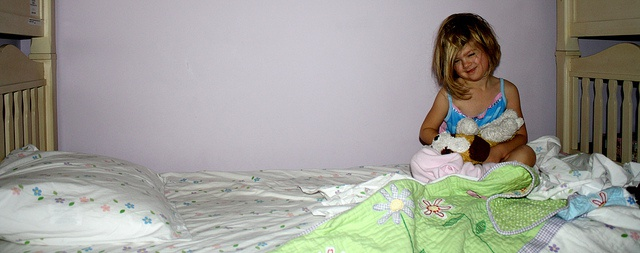Describe the objects in this image and their specific colors. I can see bed in gray, darkgray, lightgray, and lightgreen tones, people in gray, black, and maroon tones, and teddy bear in gray, darkgray, black, and lightgray tones in this image. 